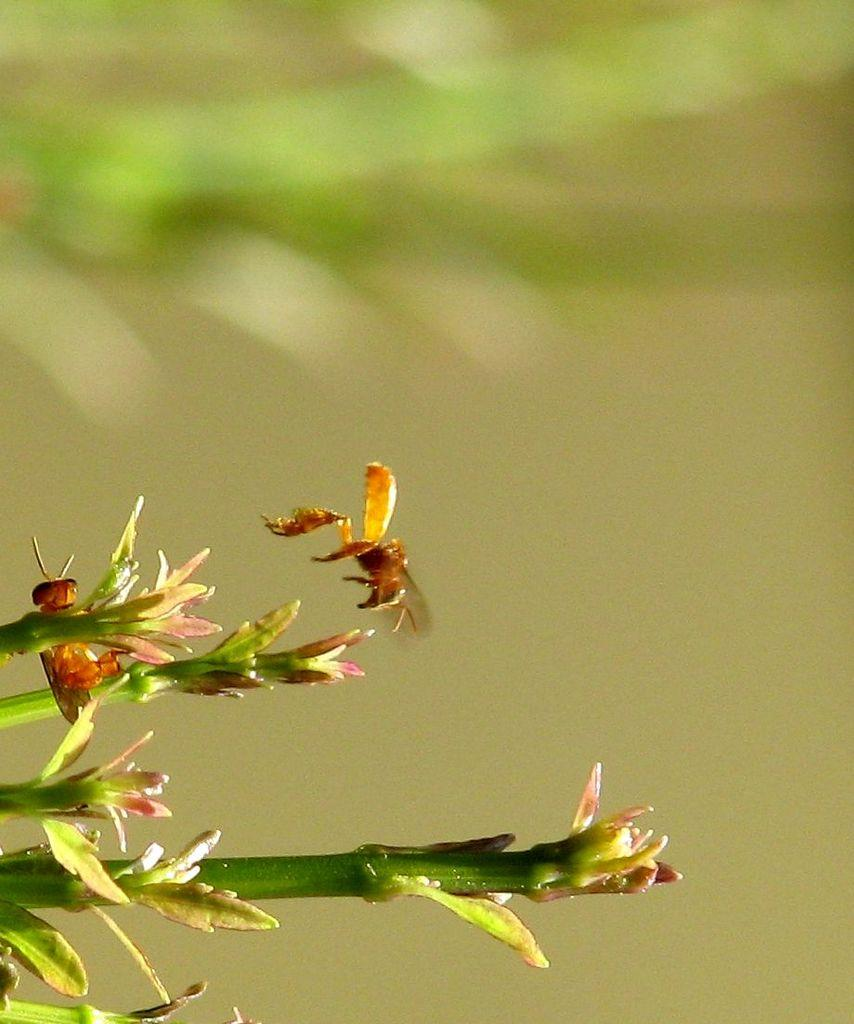What type of creature can be seen in the image? There is an insect in the image. Where is the insect located in relation to other objects in the image? The insect is near a plant. How many bears can be seen interacting with the plant in the image? There are no bears present in the image; it features an insect near a plant. What type of sponge is being used by the crow in the image? There is no crow or sponge present in the image. 